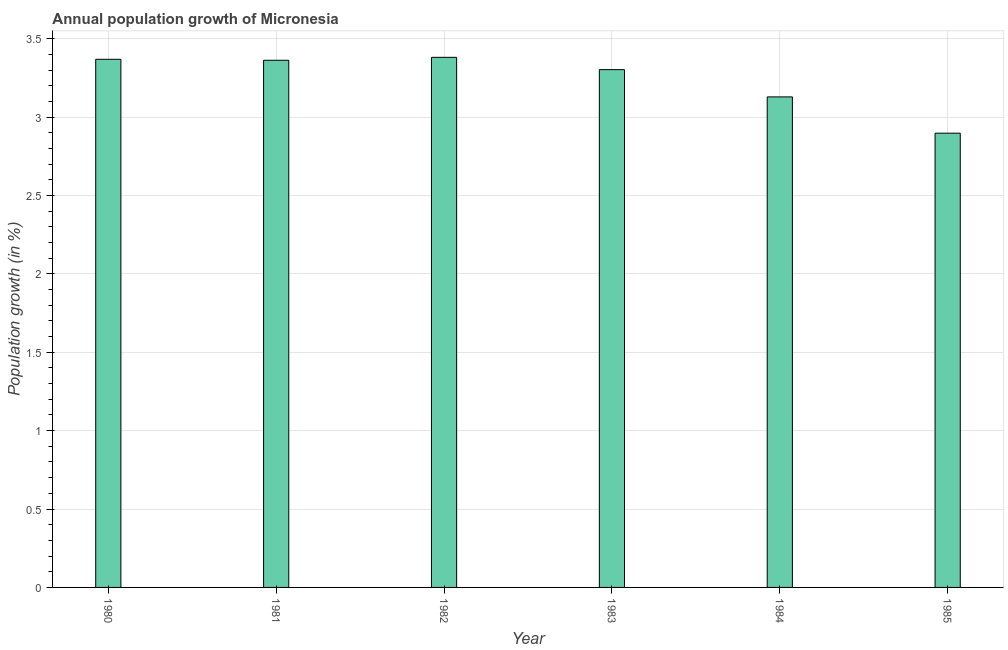Does the graph contain any zero values?
Your answer should be compact. No. What is the title of the graph?
Give a very brief answer. Annual population growth of Micronesia. What is the label or title of the X-axis?
Provide a succinct answer. Year. What is the label or title of the Y-axis?
Your answer should be compact. Population growth (in %). What is the population growth in 1984?
Offer a very short reply. 3.13. Across all years, what is the maximum population growth?
Ensure brevity in your answer.  3.38. Across all years, what is the minimum population growth?
Ensure brevity in your answer.  2.9. In which year was the population growth maximum?
Provide a short and direct response. 1982. What is the sum of the population growth?
Keep it short and to the point. 19.44. What is the difference between the population growth in 1982 and 1984?
Your answer should be compact. 0.25. What is the average population growth per year?
Your response must be concise. 3.24. What is the median population growth?
Your response must be concise. 3.33. In how many years, is the population growth greater than 1.9 %?
Offer a terse response. 6. What is the ratio of the population growth in 1980 to that in 1984?
Give a very brief answer. 1.08. Is the population growth in 1983 less than that in 1984?
Keep it short and to the point. No. What is the difference between the highest and the second highest population growth?
Make the answer very short. 0.01. What is the difference between the highest and the lowest population growth?
Your response must be concise. 0.48. How many bars are there?
Your answer should be very brief. 6. What is the Population growth (in %) in 1980?
Provide a short and direct response. 3.37. What is the Population growth (in %) of 1981?
Give a very brief answer. 3.36. What is the Population growth (in %) of 1982?
Make the answer very short. 3.38. What is the Population growth (in %) in 1983?
Provide a succinct answer. 3.3. What is the Population growth (in %) in 1984?
Provide a succinct answer. 3.13. What is the Population growth (in %) of 1985?
Your answer should be very brief. 2.9. What is the difference between the Population growth (in %) in 1980 and 1981?
Your answer should be very brief. 0.01. What is the difference between the Population growth (in %) in 1980 and 1982?
Ensure brevity in your answer.  -0.01. What is the difference between the Population growth (in %) in 1980 and 1983?
Provide a short and direct response. 0.07. What is the difference between the Population growth (in %) in 1980 and 1984?
Ensure brevity in your answer.  0.24. What is the difference between the Population growth (in %) in 1980 and 1985?
Your answer should be very brief. 0.47. What is the difference between the Population growth (in %) in 1981 and 1982?
Provide a short and direct response. -0.02. What is the difference between the Population growth (in %) in 1981 and 1983?
Offer a terse response. 0.06. What is the difference between the Population growth (in %) in 1981 and 1984?
Your answer should be compact. 0.23. What is the difference between the Population growth (in %) in 1981 and 1985?
Keep it short and to the point. 0.46. What is the difference between the Population growth (in %) in 1982 and 1983?
Make the answer very short. 0.08. What is the difference between the Population growth (in %) in 1982 and 1984?
Provide a short and direct response. 0.25. What is the difference between the Population growth (in %) in 1982 and 1985?
Provide a short and direct response. 0.48. What is the difference between the Population growth (in %) in 1983 and 1984?
Give a very brief answer. 0.17. What is the difference between the Population growth (in %) in 1983 and 1985?
Your answer should be compact. 0.41. What is the difference between the Population growth (in %) in 1984 and 1985?
Your answer should be compact. 0.23. What is the ratio of the Population growth (in %) in 1980 to that in 1981?
Keep it short and to the point. 1. What is the ratio of the Population growth (in %) in 1980 to that in 1983?
Give a very brief answer. 1.02. What is the ratio of the Population growth (in %) in 1980 to that in 1984?
Offer a very short reply. 1.08. What is the ratio of the Population growth (in %) in 1980 to that in 1985?
Offer a very short reply. 1.16. What is the ratio of the Population growth (in %) in 1981 to that in 1983?
Your response must be concise. 1.02. What is the ratio of the Population growth (in %) in 1981 to that in 1984?
Ensure brevity in your answer.  1.07. What is the ratio of the Population growth (in %) in 1981 to that in 1985?
Provide a succinct answer. 1.16. What is the ratio of the Population growth (in %) in 1982 to that in 1984?
Your response must be concise. 1.08. What is the ratio of the Population growth (in %) in 1982 to that in 1985?
Your answer should be compact. 1.17. What is the ratio of the Population growth (in %) in 1983 to that in 1984?
Keep it short and to the point. 1.06. What is the ratio of the Population growth (in %) in 1983 to that in 1985?
Your answer should be compact. 1.14. 